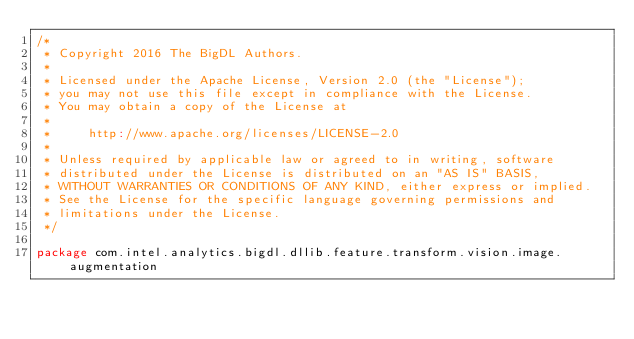<code> <loc_0><loc_0><loc_500><loc_500><_Scala_>/*
 * Copyright 2016 The BigDL Authors.
 *
 * Licensed under the Apache License, Version 2.0 (the "License");
 * you may not use this file except in compliance with the License.
 * You may obtain a copy of the License at
 *
 *     http://www.apache.org/licenses/LICENSE-2.0
 *
 * Unless required by applicable law or agreed to in writing, software
 * distributed under the License is distributed on an "AS IS" BASIS,
 * WITHOUT WARRANTIES OR CONDITIONS OF ANY KIND, either express or implied.
 * See the License for the specific language governing permissions and
 * limitations under the License.
 */

package com.intel.analytics.bigdl.dllib.feature.transform.vision.image.augmentation
</code> 